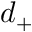Convert formula to latex. <formula><loc_0><loc_0><loc_500><loc_500>d _ { + }</formula> 